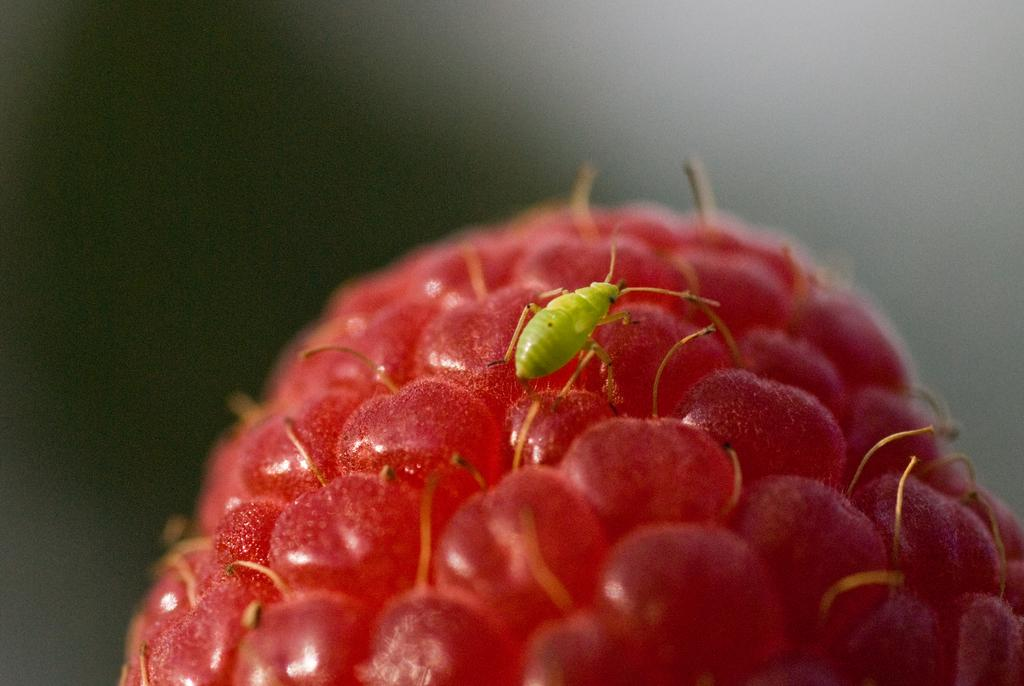What type of creature can be seen in the image? There is an insect in the image. What is the insect sitting on? The insect is on red berries. Can you describe the background of the image? The background of the image is blurry. How much money is the insect holding in the image? There is no money present in the image, and insects do not hold money. 